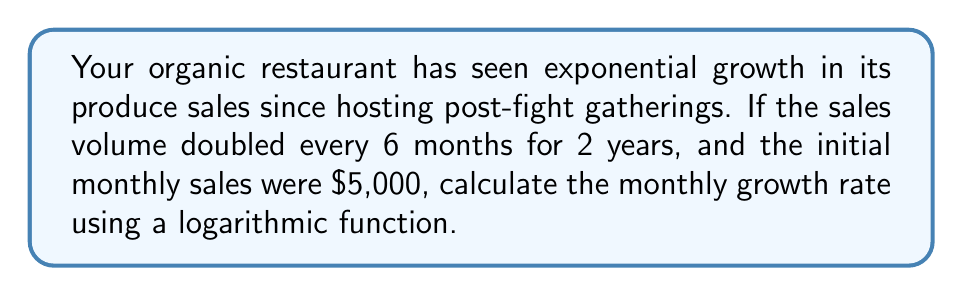Can you solve this math problem? Let's approach this step-by-step:

1) First, we need to understand what the question is asking:
   - Initial sales: $5,000 per month
   - Sales double every 6 months
   - This continues for 2 years (4 doubling periods)
   - We need to find the monthly growth rate

2) Let's use the exponential growth formula:
   $A = P(1+r)^t$
   Where:
   $A$ = Final amount
   $P$ = Initial principal balance
   $r$ = Growth rate (what we're solving for)
   $t$ = Number of time periods

3) We know that after 2 years (24 months), the sales have doubled 4 times:
   $5,000 * 2^4 = 5,000 * 16 = 80,000$

4) Now we can set up our equation:
   $80,000 = 5,000(1+r)^{24}$

5) Divide both sides by 5,000:
   $16 = (1+r)^{24}$

6) Take the natural log of both sides:
   $\ln(16) = 24\ln(1+r)$

7) Solve for $r$:
   $\frac{\ln(16)}{24} = \ln(1+r)$
   $e^{\frac{\ln(16)}{24}} = 1+r$
   $r = e^{\frac{\ln(16)}{24}} - 1$

8) Calculate:
   $r = e^{\frac{\ln(16)}{24}} - 1 \approx 0.1166 = 11.66\%$

Therefore, the monthly growth rate is approximately 11.66%.
Answer: $11.66\%$ 